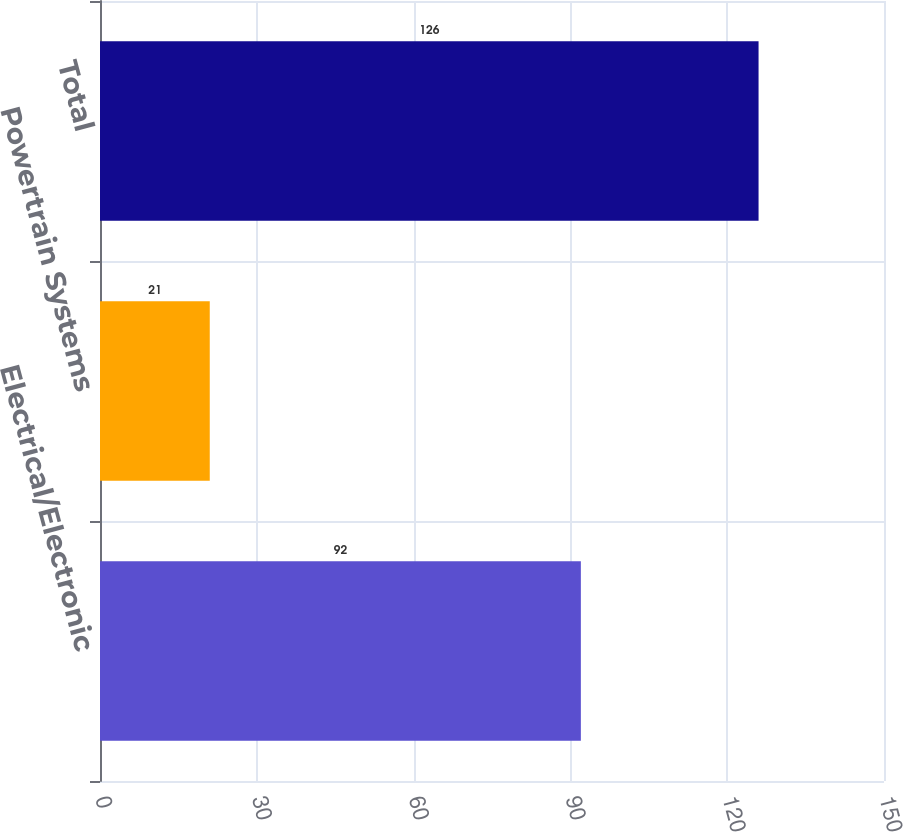Convert chart to OTSL. <chart><loc_0><loc_0><loc_500><loc_500><bar_chart><fcel>Electrical/Electronic<fcel>Powertrain Systems<fcel>Total<nl><fcel>92<fcel>21<fcel>126<nl></chart> 